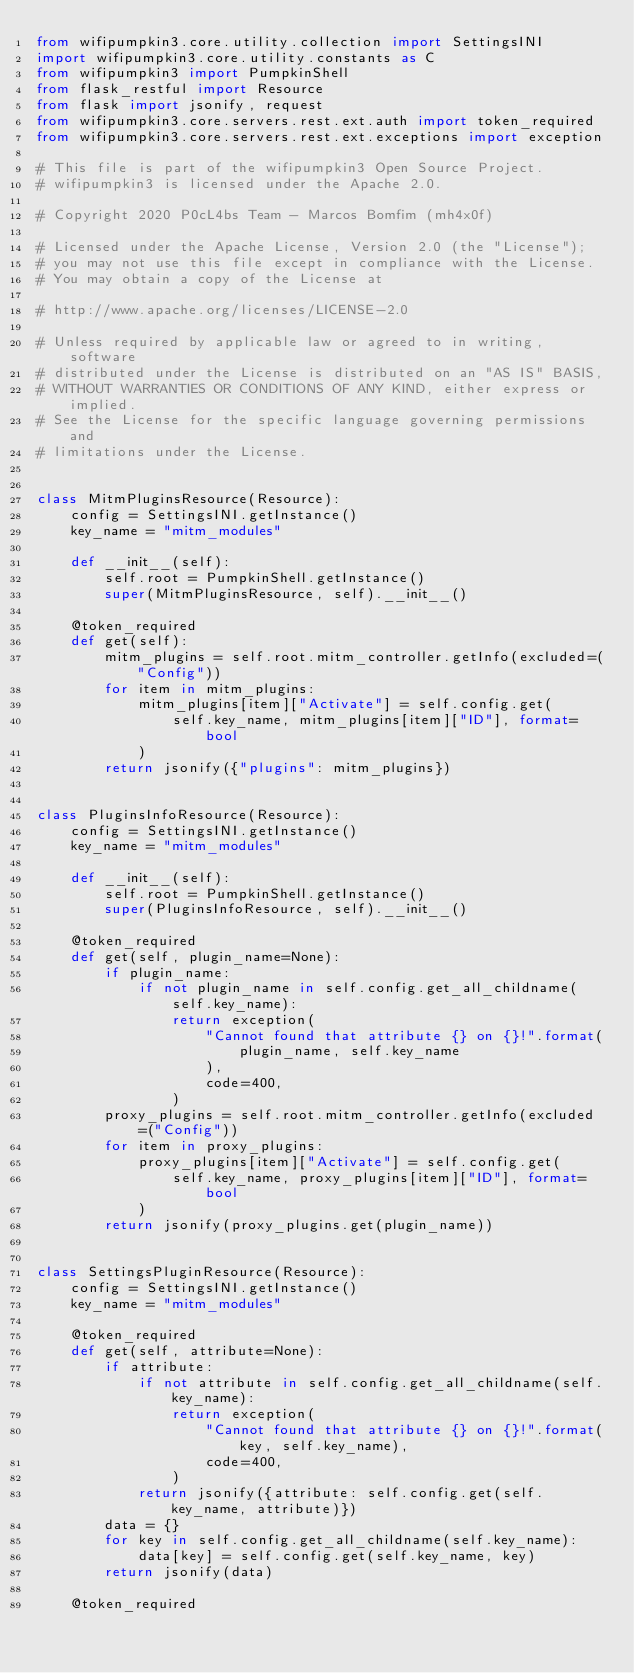<code> <loc_0><loc_0><loc_500><loc_500><_Python_>from wifipumpkin3.core.utility.collection import SettingsINI
import wifipumpkin3.core.utility.constants as C
from wifipumpkin3 import PumpkinShell
from flask_restful import Resource
from flask import jsonify, request
from wifipumpkin3.core.servers.rest.ext.auth import token_required
from wifipumpkin3.core.servers.rest.ext.exceptions import exception

# This file is part of the wifipumpkin3 Open Source Project.
# wifipumpkin3 is licensed under the Apache 2.0.

# Copyright 2020 P0cL4bs Team - Marcos Bomfim (mh4x0f)

# Licensed under the Apache License, Version 2.0 (the "License");
# you may not use this file except in compliance with the License.
# You may obtain a copy of the License at

# http://www.apache.org/licenses/LICENSE-2.0

# Unless required by applicable law or agreed to in writing, software
# distributed under the License is distributed on an "AS IS" BASIS,
# WITHOUT WARRANTIES OR CONDITIONS OF ANY KIND, either express or implied.
# See the License for the specific language governing permissions and
# limitations under the License.


class MitmPluginsResource(Resource):
    config = SettingsINI.getInstance()
    key_name = "mitm_modules"

    def __init__(self):
        self.root = PumpkinShell.getInstance()
        super(MitmPluginsResource, self).__init__()

    @token_required
    def get(self):
        mitm_plugins = self.root.mitm_controller.getInfo(excluded=("Config"))
        for item in mitm_plugins:
            mitm_plugins[item]["Activate"] = self.config.get(
                self.key_name, mitm_plugins[item]["ID"], format=bool
            )
        return jsonify({"plugins": mitm_plugins})


class PluginsInfoResource(Resource):
    config = SettingsINI.getInstance()
    key_name = "mitm_modules"

    def __init__(self):
        self.root = PumpkinShell.getInstance()
        super(PluginsInfoResource, self).__init__()

    @token_required
    def get(self, plugin_name=None):
        if plugin_name:
            if not plugin_name in self.config.get_all_childname(self.key_name):
                return exception(
                    "Cannot found that attribute {} on {}!".format(
                        plugin_name, self.key_name
                    ),
                    code=400,
                )
        proxy_plugins = self.root.mitm_controller.getInfo(excluded=("Config"))
        for item in proxy_plugins:
            proxy_plugins[item]["Activate"] = self.config.get(
                self.key_name, proxy_plugins[item]["ID"], format=bool
            )
        return jsonify(proxy_plugins.get(plugin_name))


class SettingsPluginResource(Resource):
    config = SettingsINI.getInstance()
    key_name = "mitm_modules"

    @token_required
    def get(self, attribute=None):
        if attribute:
            if not attribute in self.config.get_all_childname(self.key_name):
                return exception(
                    "Cannot found that attribute {} on {}!".format(key, self.key_name),
                    code=400,
                )
            return jsonify({attribute: self.config.get(self.key_name, attribute)})
        data = {}
        for key in self.config.get_all_childname(self.key_name):
            data[key] = self.config.get(self.key_name, key)
        return jsonify(data)

    @token_required</code> 